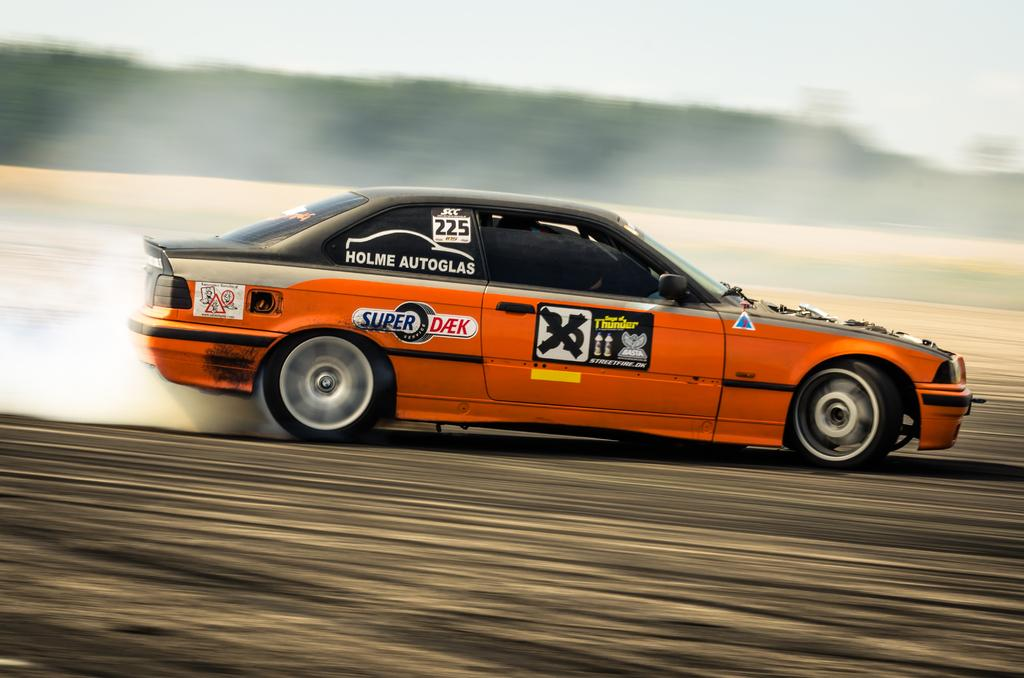What is the main subject in the center of the image? There is a car in the center of the image. What can be seen in the background of the image? There are trees and the sky visible in the background of the image. What else is visible in the background of the image? The ground is also visible in the background of the image. What type of vessel is being used to say good-bye in the image? There is no vessel or good-bye scene present in the image; it features a car and background elements. 